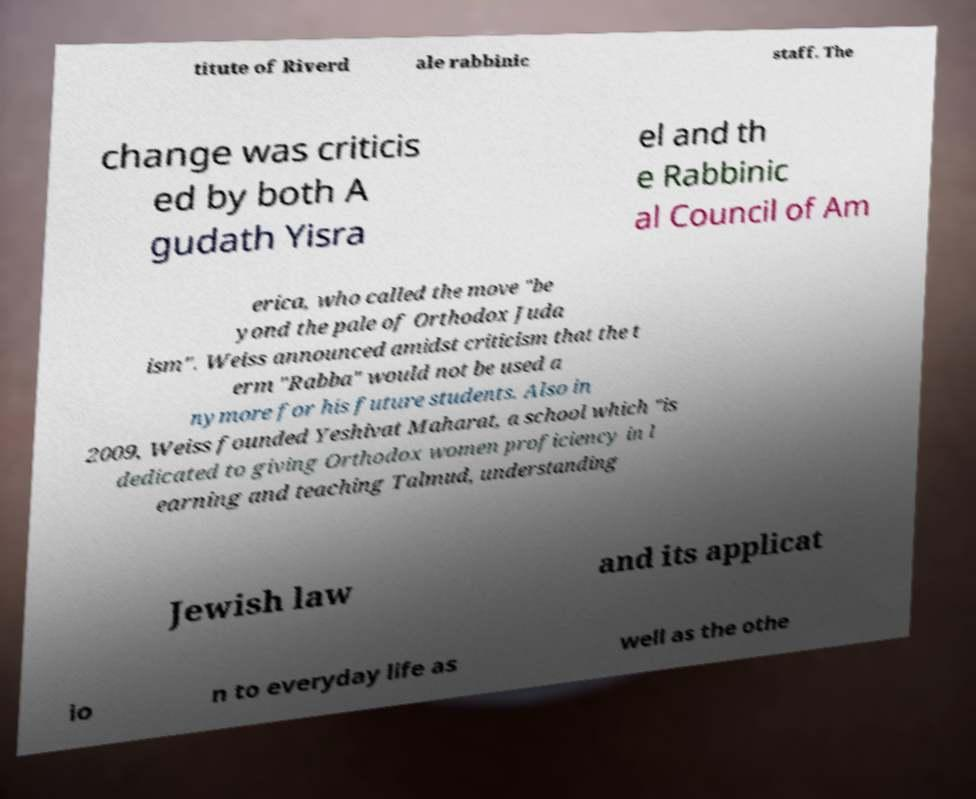Can you read and provide the text displayed in the image?This photo seems to have some interesting text. Can you extract and type it out for me? titute of Riverd ale rabbinic staff. The change was criticis ed by both A gudath Yisra el and th e Rabbinic al Council of Am erica, who called the move "be yond the pale of Orthodox Juda ism". Weiss announced amidst criticism that the t erm "Rabba" would not be used a nymore for his future students. Also in 2009, Weiss founded Yeshivat Maharat, a school which "is dedicated to giving Orthodox women proficiency in l earning and teaching Talmud, understanding Jewish law and its applicat io n to everyday life as well as the othe 